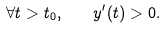<formula> <loc_0><loc_0><loc_500><loc_500>\forall t > t _ { 0 } , \quad y ^ { \prime } ( t ) > 0 .</formula> 